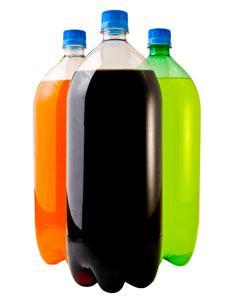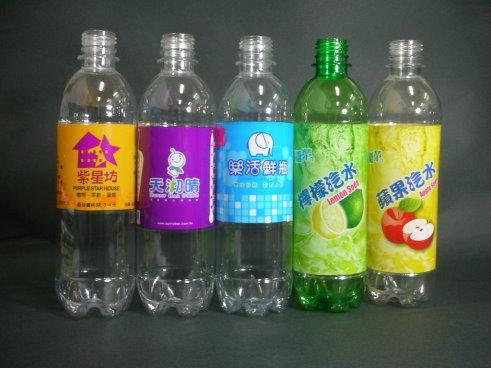The first image is the image on the left, the second image is the image on the right. Given the left and right images, does the statement "All bottles are displayed upright, some bottles are not touching another bottle, and all bottles have printed labels on them." hold true? Answer yes or no. No. The first image is the image on the left, the second image is the image on the right. Evaluate the accuracy of this statement regarding the images: "There are at least seven bottles in total.". Is it true? Answer yes or no. Yes. 